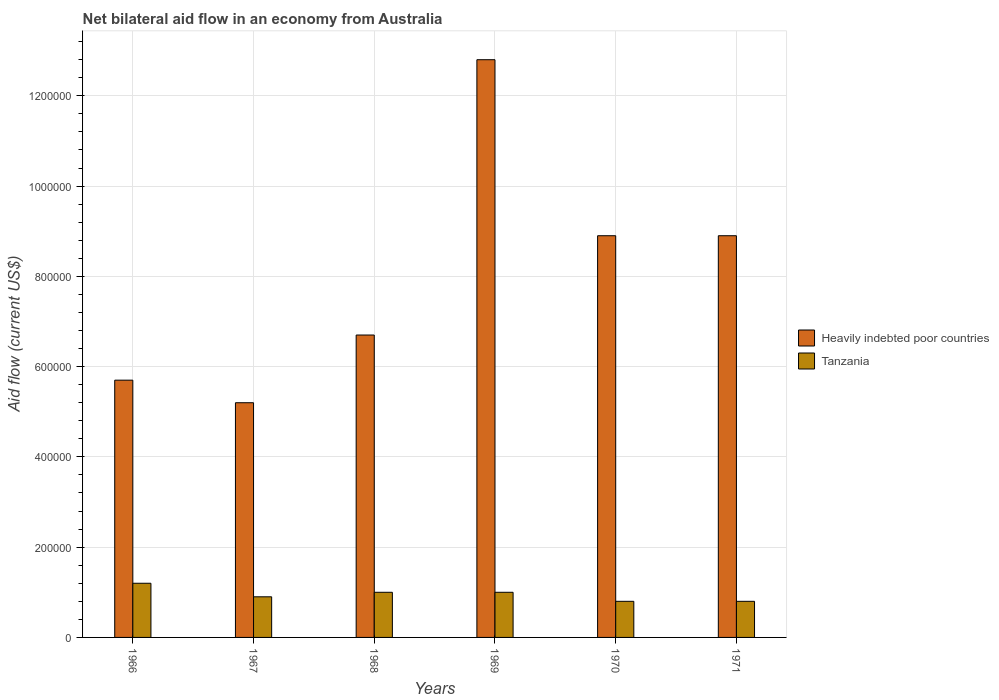How many different coloured bars are there?
Make the answer very short. 2. How many groups of bars are there?
Make the answer very short. 6. Are the number of bars per tick equal to the number of legend labels?
Keep it short and to the point. Yes. How many bars are there on the 4th tick from the right?
Offer a very short reply. 2. What is the label of the 1st group of bars from the left?
Provide a short and direct response. 1966. In how many cases, is the number of bars for a given year not equal to the number of legend labels?
Make the answer very short. 0. What is the net bilateral aid flow in Tanzania in 1968?
Offer a very short reply. 1.00e+05. Across all years, what is the maximum net bilateral aid flow in Heavily indebted poor countries?
Provide a short and direct response. 1.28e+06. Across all years, what is the minimum net bilateral aid flow in Heavily indebted poor countries?
Offer a terse response. 5.20e+05. In which year was the net bilateral aid flow in Tanzania maximum?
Provide a succinct answer. 1966. In which year was the net bilateral aid flow in Heavily indebted poor countries minimum?
Your response must be concise. 1967. What is the total net bilateral aid flow in Tanzania in the graph?
Offer a terse response. 5.70e+05. What is the difference between the net bilateral aid flow in Heavily indebted poor countries in 1967 and that in 1968?
Give a very brief answer. -1.50e+05. What is the difference between the net bilateral aid flow in Tanzania in 1968 and the net bilateral aid flow in Heavily indebted poor countries in 1966?
Ensure brevity in your answer.  -4.70e+05. What is the average net bilateral aid flow in Heavily indebted poor countries per year?
Offer a terse response. 8.03e+05. In the year 1971, what is the difference between the net bilateral aid flow in Heavily indebted poor countries and net bilateral aid flow in Tanzania?
Provide a succinct answer. 8.10e+05. In how many years, is the net bilateral aid flow in Heavily indebted poor countries greater than 680000 US$?
Your response must be concise. 3. What is the ratio of the net bilateral aid flow in Heavily indebted poor countries in 1966 to that in 1969?
Provide a succinct answer. 0.45. What is the difference between the highest and the lowest net bilateral aid flow in Heavily indebted poor countries?
Keep it short and to the point. 7.60e+05. In how many years, is the net bilateral aid flow in Tanzania greater than the average net bilateral aid flow in Tanzania taken over all years?
Provide a short and direct response. 3. Is the sum of the net bilateral aid flow in Heavily indebted poor countries in 1969 and 1971 greater than the maximum net bilateral aid flow in Tanzania across all years?
Your answer should be compact. Yes. What does the 2nd bar from the left in 1969 represents?
Give a very brief answer. Tanzania. What does the 2nd bar from the right in 1966 represents?
Your answer should be compact. Heavily indebted poor countries. How many bars are there?
Offer a very short reply. 12. How many years are there in the graph?
Ensure brevity in your answer.  6. What is the difference between two consecutive major ticks on the Y-axis?
Offer a terse response. 2.00e+05. Are the values on the major ticks of Y-axis written in scientific E-notation?
Keep it short and to the point. No. Does the graph contain any zero values?
Your answer should be very brief. No. Where does the legend appear in the graph?
Your answer should be very brief. Center right. What is the title of the graph?
Provide a short and direct response. Net bilateral aid flow in an economy from Australia. What is the Aid flow (current US$) in Heavily indebted poor countries in 1966?
Ensure brevity in your answer.  5.70e+05. What is the Aid flow (current US$) of Heavily indebted poor countries in 1967?
Give a very brief answer. 5.20e+05. What is the Aid flow (current US$) in Heavily indebted poor countries in 1968?
Offer a terse response. 6.70e+05. What is the Aid flow (current US$) of Tanzania in 1968?
Provide a short and direct response. 1.00e+05. What is the Aid flow (current US$) of Heavily indebted poor countries in 1969?
Give a very brief answer. 1.28e+06. What is the Aid flow (current US$) of Heavily indebted poor countries in 1970?
Your answer should be very brief. 8.90e+05. What is the Aid flow (current US$) in Heavily indebted poor countries in 1971?
Offer a very short reply. 8.90e+05. What is the Aid flow (current US$) in Tanzania in 1971?
Keep it short and to the point. 8.00e+04. Across all years, what is the maximum Aid flow (current US$) of Heavily indebted poor countries?
Keep it short and to the point. 1.28e+06. Across all years, what is the minimum Aid flow (current US$) of Heavily indebted poor countries?
Offer a terse response. 5.20e+05. Across all years, what is the minimum Aid flow (current US$) in Tanzania?
Ensure brevity in your answer.  8.00e+04. What is the total Aid flow (current US$) in Heavily indebted poor countries in the graph?
Offer a very short reply. 4.82e+06. What is the total Aid flow (current US$) in Tanzania in the graph?
Provide a succinct answer. 5.70e+05. What is the difference between the Aid flow (current US$) in Heavily indebted poor countries in 1966 and that in 1967?
Your response must be concise. 5.00e+04. What is the difference between the Aid flow (current US$) in Heavily indebted poor countries in 1966 and that in 1968?
Your response must be concise. -1.00e+05. What is the difference between the Aid flow (current US$) in Heavily indebted poor countries in 1966 and that in 1969?
Provide a short and direct response. -7.10e+05. What is the difference between the Aid flow (current US$) in Tanzania in 1966 and that in 1969?
Keep it short and to the point. 2.00e+04. What is the difference between the Aid flow (current US$) of Heavily indebted poor countries in 1966 and that in 1970?
Offer a very short reply. -3.20e+05. What is the difference between the Aid flow (current US$) in Tanzania in 1966 and that in 1970?
Give a very brief answer. 4.00e+04. What is the difference between the Aid flow (current US$) in Heavily indebted poor countries in 1966 and that in 1971?
Keep it short and to the point. -3.20e+05. What is the difference between the Aid flow (current US$) of Tanzania in 1966 and that in 1971?
Make the answer very short. 4.00e+04. What is the difference between the Aid flow (current US$) in Heavily indebted poor countries in 1967 and that in 1968?
Your answer should be very brief. -1.50e+05. What is the difference between the Aid flow (current US$) of Heavily indebted poor countries in 1967 and that in 1969?
Provide a short and direct response. -7.60e+05. What is the difference between the Aid flow (current US$) in Heavily indebted poor countries in 1967 and that in 1970?
Give a very brief answer. -3.70e+05. What is the difference between the Aid flow (current US$) in Tanzania in 1967 and that in 1970?
Your answer should be compact. 10000. What is the difference between the Aid flow (current US$) in Heavily indebted poor countries in 1967 and that in 1971?
Your response must be concise. -3.70e+05. What is the difference between the Aid flow (current US$) of Tanzania in 1967 and that in 1971?
Offer a very short reply. 10000. What is the difference between the Aid flow (current US$) of Heavily indebted poor countries in 1968 and that in 1969?
Make the answer very short. -6.10e+05. What is the difference between the Aid flow (current US$) in Heavily indebted poor countries in 1968 and that in 1970?
Provide a short and direct response. -2.20e+05. What is the difference between the Aid flow (current US$) of Heavily indebted poor countries in 1969 and that in 1970?
Provide a succinct answer. 3.90e+05. What is the difference between the Aid flow (current US$) in Heavily indebted poor countries in 1969 and that in 1971?
Your answer should be very brief. 3.90e+05. What is the difference between the Aid flow (current US$) of Heavily indebted poor countries in 1970 and that in 1971?
Your answer should be compact. 0. What is the difference between the Aid flow (current US$) of Tanzania in 1970 and that in 1971?
Provide a short and direct response. 0. What is the difference between the Aid flow (current US$) of Heavily indebted poor countries in 1966 and the Aid flow (current US$) of Tanzania in 1970?
Keep it short and to the point. 4.90e+05. What is the difference between the Aid flow (current US$) of Heavily indebted poor countries in 1968 and the Aid flow (current US$) of Tanzania in 1969?
Keep it short and to the point. 5.70e+05. What is the difference between the Aid flow (current US$) of Heavily indebted poor countries in 1968 and the Aid flow (current US$) of Tanzania in 1970?
Ensure brevity in your answer.  5.90e+05. What is the difference between the Aid flow (current US$) in Heavily indebted poor countries in 1968 and the Aid flow (current US$) in Tanzania in 1971?
Make the answer very short. 5.90e+05. What is the difference between the Aid flow (current US$) of Heavily indebted poor countries in 1969 and the Aid flow (current US$) of Tanzania in 1970?
Your answer should be very brief. 1.20e+06. What is the difference between the Aid flow (current US$) of Heavily indebted poor countries in 1969 and the Aid flow (current US$) of Tanzania in 1971?
Your answer should be very brief. 1.20e+06. What is the difference between the Aid flow (current US$) in Heavily indebted poor countries in 1970 and the Aid flow (current US$) in Tanzania in 1971?
Your answer should be very brief. 8.10e+05. What is the average Aid flow (current US$) of Heavily indebted poor countries per year?
Your answer should be compact. 8.03e+05. What is the average Aid flow (current US$) of Tanzania per year?
Offer a very short reply. 9.50e+04. In the year 1967, what is the difference between the Aid flow (current US$) of Heavily indebted poor countries and Aid flow (current US$) of Tanzania?
Your answer should be very brief. 4.30e+05. In the year 1968, what is the difference between the Aid flow (current US$) of Heavily indebted poor countries and Aid flow (current US$) of Tanzania?
Keep it short and to the point. 5.70e+05. In the year 1969, what is the difference between the Aid flow (current US$) in Heavily indebted poor countries and Aid flow (current US$) in Tanzania?
Provide a succinct answer. 1.18e+06. In the year 1970, what is the difference between the Aid flow (current US$) of Heavily indebted poor countries and Aid flow (current US$) of Tanzania?
Your answer should be very brief. 8.10e+05. In the year 1971, what is the difference between the Aid flow (current US$) of Heavily indebted poor countries and Aid flow (current US$) of Tanzania?
Offer a terse response. 8.10e+05. What is the ratio of the Aid flow (current US$) of Heavily indebted poor countries in 1966 to that in 1967?
Give a very brief answer. 1.1. What is the ratio of the Aid flow (current US$) in Heavily indebted poor countries in 1966 to that in 1968?
Your answer should be very brief. 0.85. What is the ratio of the Aid flow (current US$) of Heavily indebted poor countries in 1966 to that in 1969?
Offer a terse response. 0.45. What is the ratio of the Aid flow (current US$) in Tanzania in 1966 to that in 1969?
Your response must be concise. 1.2. What is the ratio of the Aid flow (current US$) of Heavily indebted poor countries in 1966 to that in 1970?
Make the answer very short. 0.64. What is the ratio of the Aid flow (current US$) of Heavily indebted poor countries in 1966 to that in 1971?
Give a very brief answer. 0.64. What is the ratio of the Aid flow (current US$) in Tanzania in 1966 to that in 1971?
Offer a very short reply. 1.5. What is the ratio of the Aid flow (current US$) in Heavily indebted poor countries in 1967 to that in 1968?
Provide a succinct answer. 0.78. What is the ratio of the Aid flow (current US$) of Tanzania in 1967 to that in 1968?
Your answer should be compact. 0.9. What is the ratio of the Aid flow (current US$) of Heavily indebted poor countries in 1967 to that in 1969?
Ensure brevity in your answer.  0.41. What is the ratio of the Aid flow (current US$) in Heavily indebted poor countries in 1967 to that in 1970?
Give a very brief answer. 0.58. What is the ratio of the Aid flow (current US$) of Heavily indebted poor countries in 1967 to that in 1971?
Your response must be concise. 0.58. What is the ratio of the Aid flow (current US$) of Tanzania in 1967 to that in 1971?
Keep it short and to the point. 1.12. What is the ratio of the Aid flow (current US$) in Heavily indebted poor countries in 1968 to that in 1969?
Keep it short and to the point. 0.52. What is the ratio of the Aid flow (current US$) of Tanzania in 1968 to that in 1969?
Your answer should be compact. 1. What is the ratio of the Aid flow (current US$) in Heavily indebted poor countries in 1968 to that in 1970?
Offer a very short reply. 0.75. What is the ratio of the Aid flow (current US$) in Tanzania in 1968 to that in 1970?
Offer a very short reply. 1.25. What is the ratio of the Aid flow (current US$) in Heavily indebted poor countries in 1968 to that in 1971?
Your response must be concise. 0.75. What is the ratio of the Aid flow (current US$) of Heavily indebted poor countries in 1969 to that in 1970?
Your answer should be compact. 1.44. What is the ratio of the Aid flow (current US$) of Tanzania in 1969 to that in 1970?
Keep it short and to the point. 1.25. What is the ratio of the Aid flow (current US$) of Heavily indebted poor countries in 1969 to that in 1971?
Provide a succinct answer. 1.44. What is the ratio of the Aid flow (current US$) of Heavily indebted poor countries in 1970 to that in 1971?
Give a very brief answer. 1. What is the ratio of the Aid flow (current US$) in Tanzania in 1970 to that in 1971?
Your answer should be very brief. 1. What is the difference between the highest and the second highest Aid flow (current US$) in Heavily indebted poor countries?
Your answer should be very brief. 3.90e+05. What is the difference between the highest and the second highest Aid flow (current US$) in Tanzania?
Give a very brief answer. 2.00e+04. What is the difference between the highest and the lowest Aid flow (current US$) in Heavily indebted poor countries?
Give a very brief answer. 7.60e+05. 